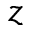<formula> <loc_0><loc_0><loc_500><loc_500>z</formula> 